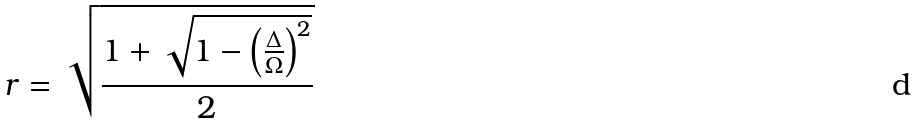Convert formula to latex. <formula><loc_0><loc_0><loc_500><loc_500>r = \sqrt { \frac { 1 + \sqrt { 1 - \left ( \frac { \Delta } { \Omega } \right ) ^ { 2 } } } { 2 } }</formula> 